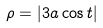Convert formula to latex. <formula><loc_0><loc_0><loc_500><loc_500>\rho = | 3 a \cos t |</formula> 